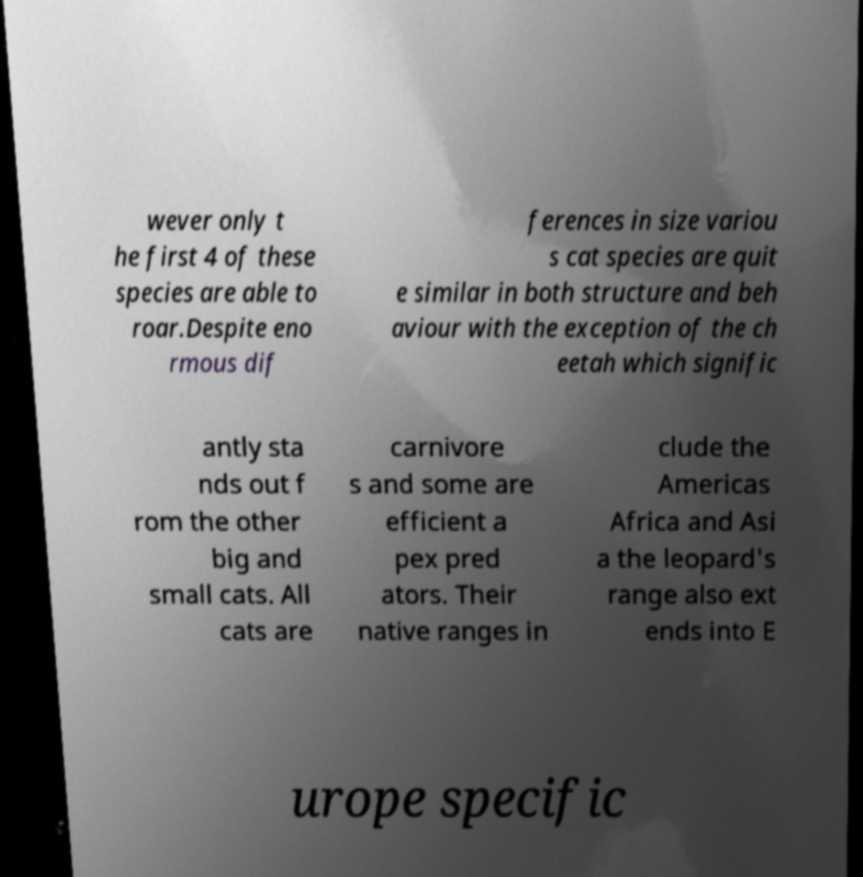What messages or text are displayed in this image? I need them in a readable, typed format. wever only t he first 4 of these species are able to roar.Despite eno rmous dif ferences in size variou s cat species are quit e similar in both structure and beh aviour with the exception of the ch eetah which signific antly sta nds out f rom the other big and small cats. All cats are carnivore s and some are efficient a pex pred ators. Their native ranges in clude the Americas Africa and Asi a the leopard's range also ext ends into E urope specific 